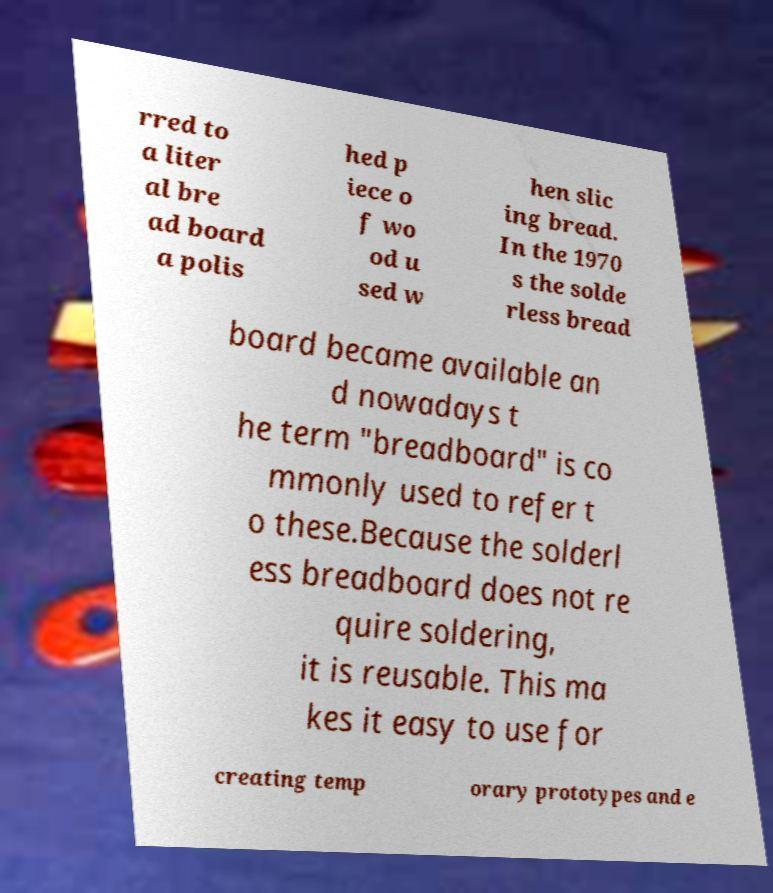Could you extract and type out the text from this image? rred to a liter al bre ad board a polis hed p iece o f wo od u sed w hen slic ing bread. In the 1970 s the solde rless bread board became available an d nowadays t he term "breadboard" is co mmonly used to refer t o these.Because the solderl ess breadboard does not re quire soldering, it is reusable. This ma kes it easy to use for creating temp orary prototypes and e 